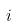<formula> <loc_0><loc_0><loc_500><loc_500>i</formula> 